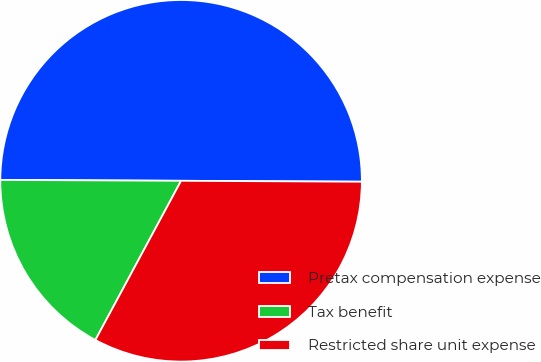Convert chart to OTSL. <chart><loc_0><loc_0><loc_500><loc_500><pie_chart><fcel>Pretax compensation expense<fcel>Tax benefit<fcel>Restricted share unit expense<nl><fcel>50.0%<fcel>17.22%<fcel>32.78%<nl></chart> 